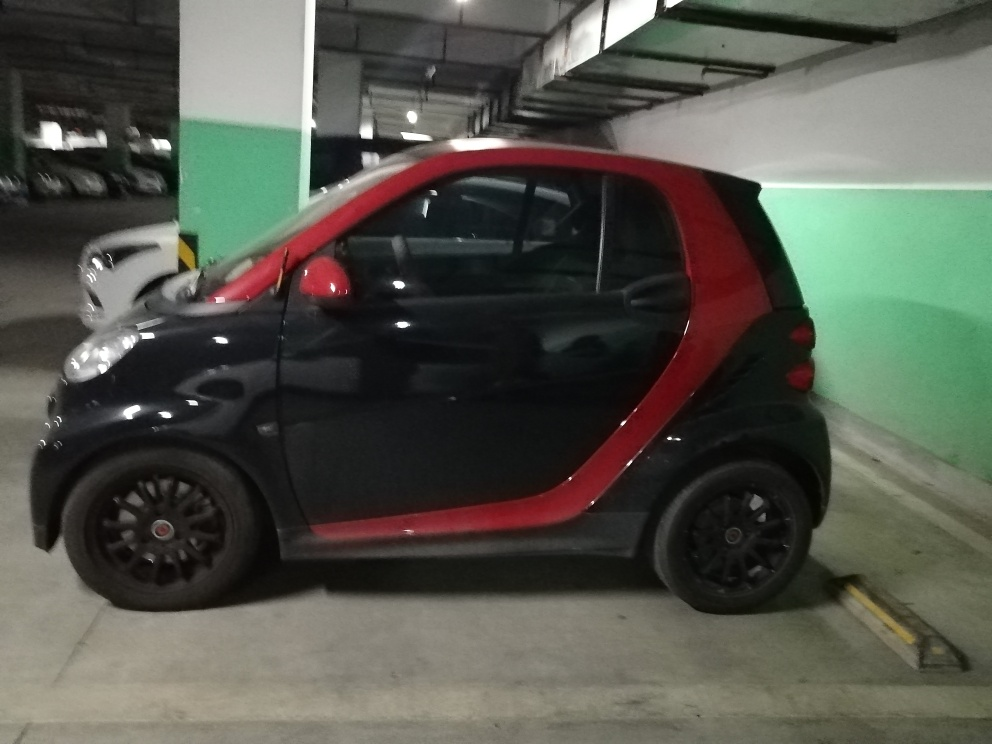Is the image completely free from any quality issues? The image could be improved with better lighting and focus to enhance clarity and detail, as currently it's underexposed, and the edges are not sharp. Additionally, framing the subject to avoid the cut-off areas, such as the front of the car and the surroundings, would present a better composition. 